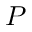<formula> <loc_0><loc_0><loc_500><loc_500>P</formula> 